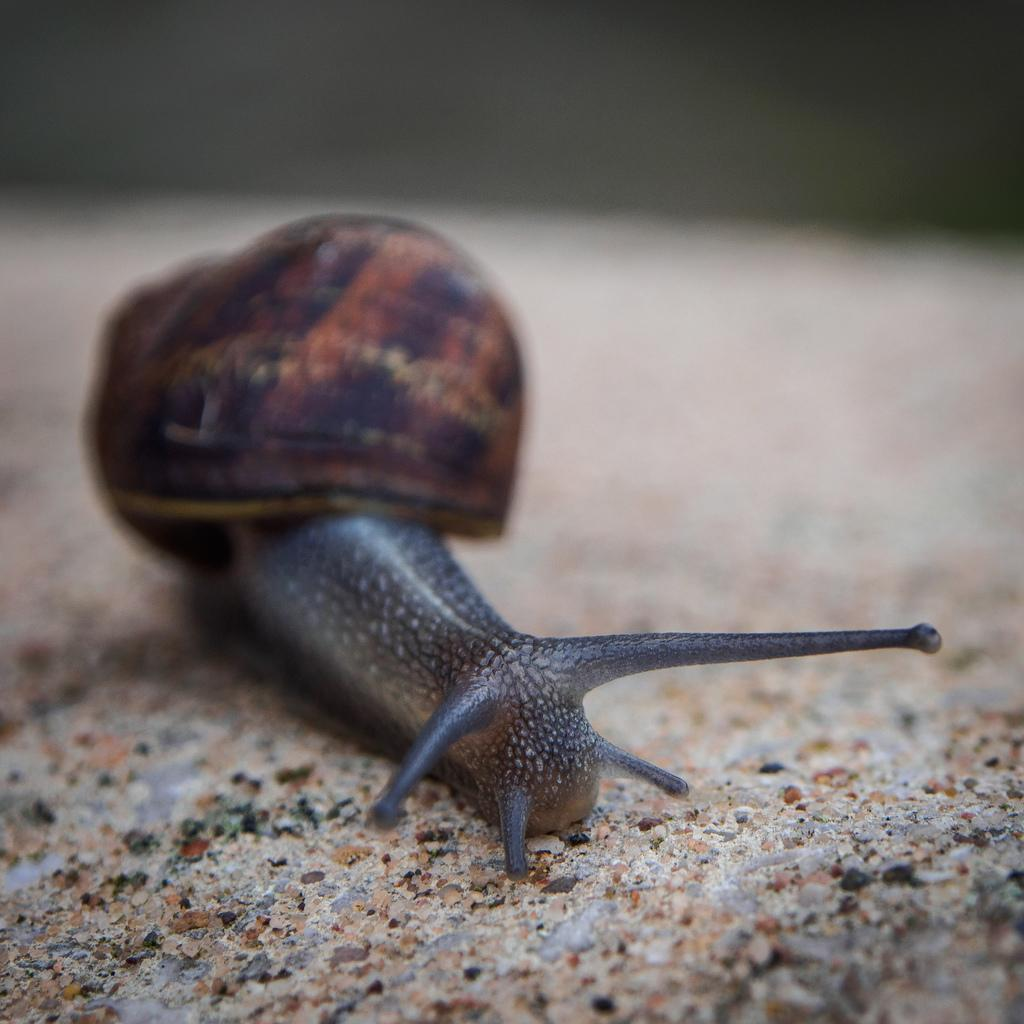What type of animal is in the image? There is a snail in the image. What colors can be seen on the snail? The snail is brown, blue, and black in color. Where is the snail located in the image? The snail is on the sand. Can you describe the background of the image? The background of the image is blurred. What type of coal is being used by the dad in the image? There is no dad or coal present in the image; it features a snail on the sand with a blurred background. 